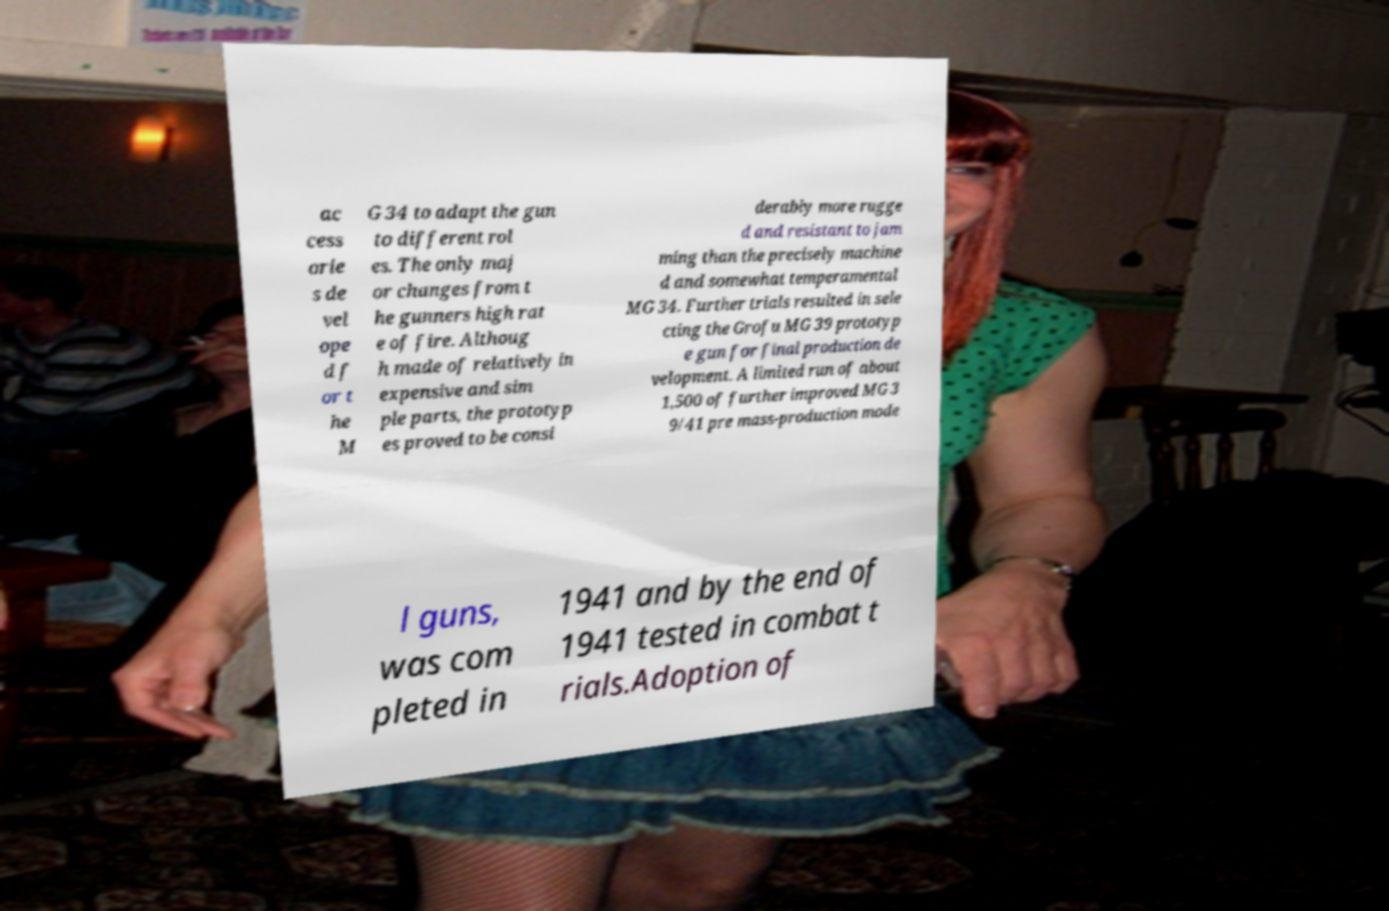Can you accurately transcribe the text from the provided image for me? ac cess orie s de vel ope d f or t he M G 34 to adapt the gun to different rol es. The only maj or changes from t he gunners high rat e of fire. Althoug h made of relatively in expensive and sim ple parts, the prototyp es proved to be consi derably more rugge d and resistant to jam ming than the precisely machine d and somewhat temperamental MG 34. Further trials resulted in sele cting the Grofu MG 39 prototyp e gun for final production de velopment. A limited run of about 1,500 of further improved MG 3 9/41 pre mass-production mode l guns, was com pleted in 1941 and by the end of 1941 tested in combat t rials.Adoption of 